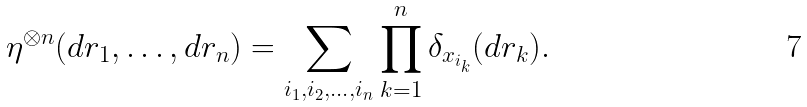Convert formula to latex. <formula><loc_0><loc_0><loc_500><loc_500>\eta ^ { \otimes n } ( d r _ { 1 } , \dots , d r _ { n } ) = \sum _ { i _ { 1 } , i _ { 2 } , \dots , i _ { n } } \prod _ { k = 1 } ^ { n } \delta _ { x _ { i _ { k } } } ( d r _ { k } ) .</formula> 